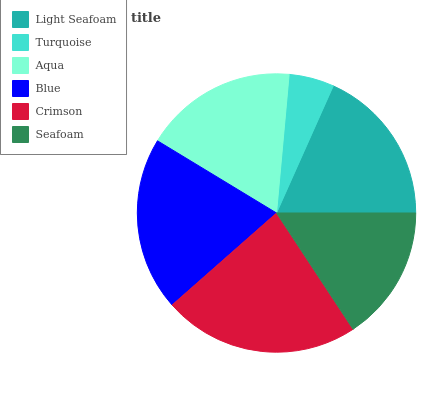Is Turquoise the minimum?
Answer yes or no. Yes. Is Crimson the maximum?
Answer yes or no. Yes. Is Aqua the minimum?
Answer yes or no. No. Is Aqua the maximum?
Answer yes or no. No. Is Aqua greater than Turquoise?
Answer yes or no. Yes. Is Turquoise less than Aqua?
Answer yes or no. Yes. Is Turquoise greater than Aqua?
Answer yes or no. No. Is Aqua less than Turquoise?
Answer yes or no. No. Is Light Seafoam the high median?
Answer yes or no. Yes. Is Aqua the low median?
Answer yes or no. Yes. Is Seafoam the high median?
Answer yes or no. No. Is Blue the low median?
Answer yes or no. No. 